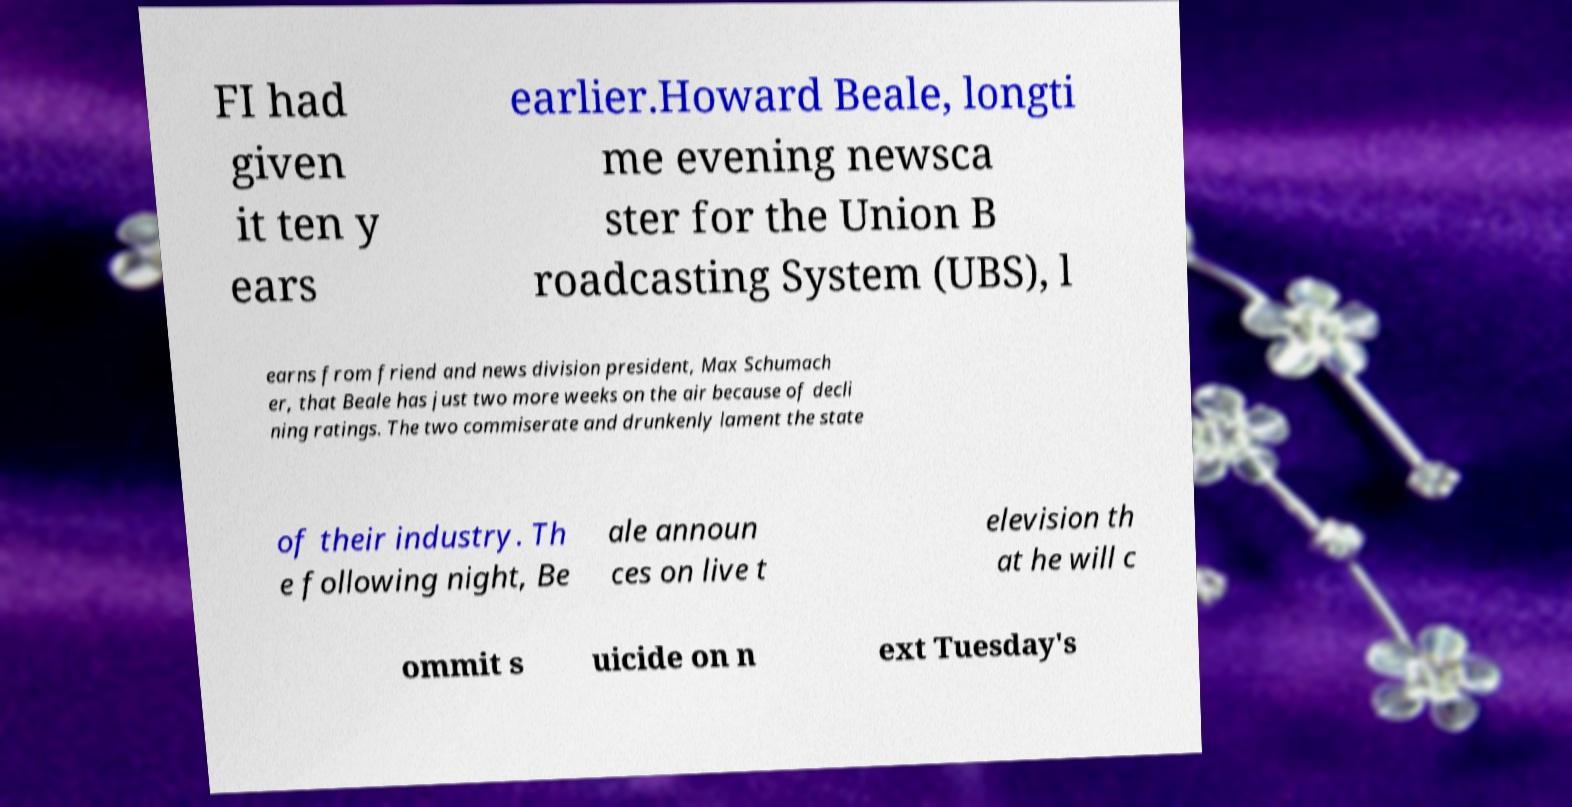Could you extract and type out the text from this image? FI had given it ten y ears earlier.Howard Beale, longti me evening newsca ster for the Union B roadcasting System (UBS), l earns from friend and news division president, Max Schumach er, that Beale has just two more weeks on the air because of decli ning ratings. The two commiserate and drunkenly lament the state of their industry. Th e following night, Be ale announ ces on live t elevision th at he will c ommit s uicide on n ext Tuesday's 